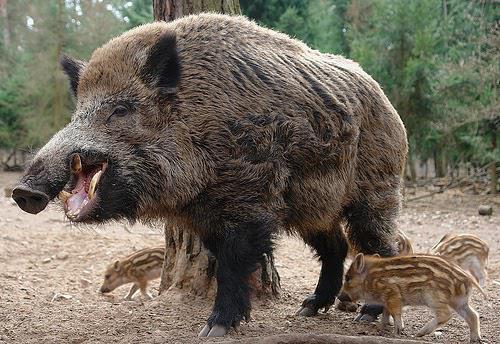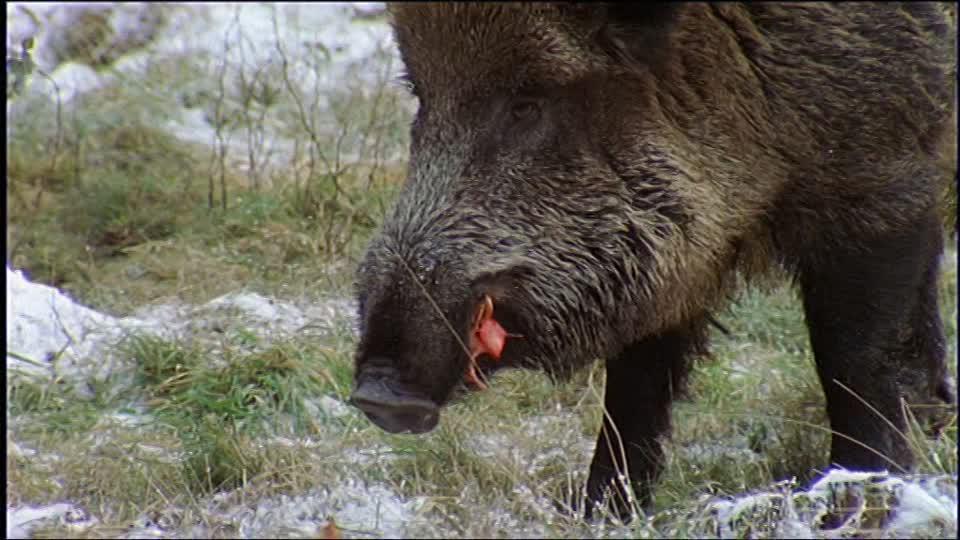The first image is the image on the left, the second image is the image on the right. Evaluate the accuracy of this statement regarding the images: "At least one image features multiple full grown warthogs.". Is it true? Answer yes or no. No. 